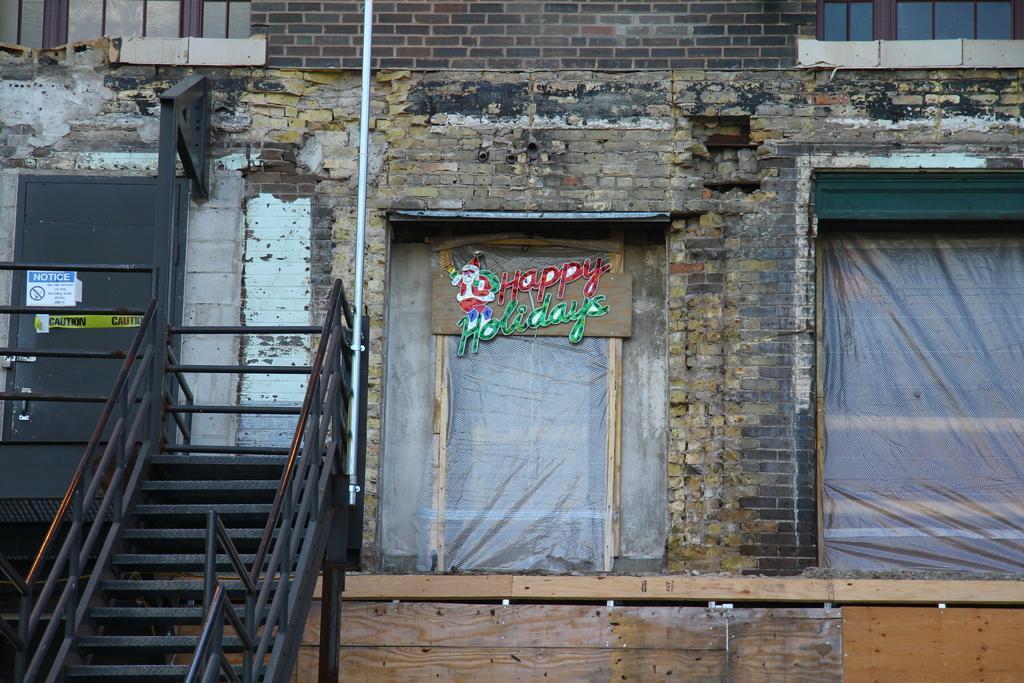Can you describe this image briefly? In this image there is a building, in front of the building there are stairs, beside that there are windows. On the one of the window there is some text. 